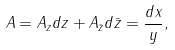Convert formula to latex. <formula><loc_0><loc_0><loc_500><loc_500>A = A _ { z } d z + A _ { \bar { z } } d \bar { z } = { \frac { d x } { y } } ,</formula> 